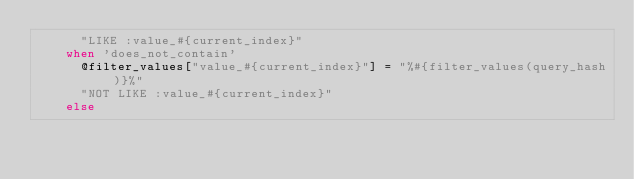Convert code to text. <code><loc_0><loc_0><loc_500><loc_500><_Ruby_>      "LIKE :value_#{current_index}"
    when 'does_not_contain'
      @filter_values["value_#{current_index}"] = "%#{filter_values(query_hash)}%"
      "NOT LIKE :value_#{current_index}"
    else</code> 